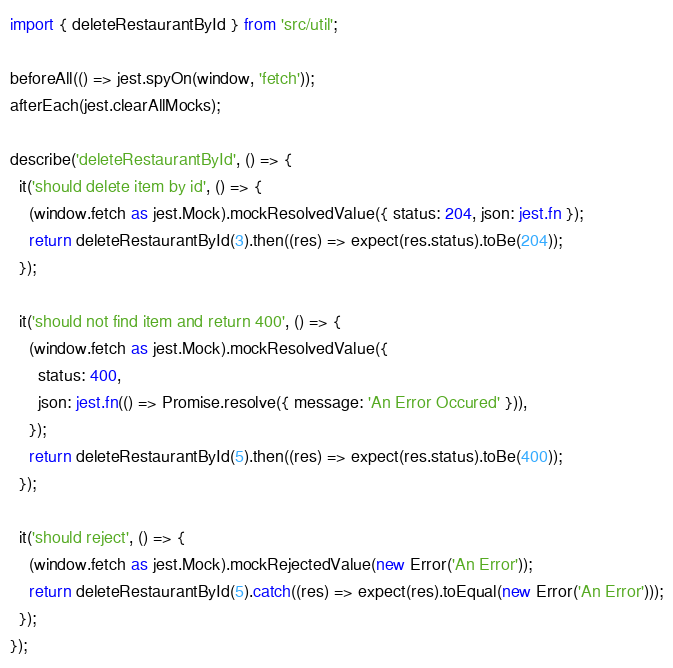<code> <loc_0><loc_0><loc_500><loc_500><_TypeScript_>import { deleteRestaurantById } from 'src/util';

beforeAll(() => jest.spyOn(window, 'fetch'));
afterEach(jest.clearAllMocks);

describe('deleteRestaurantById', () => {
  it('should delete item by id', () => {
    (window.fetch as jest.Mock).mockResolvedValue({ status: 204, json: jest.fn });
    return deleteRestaurantById(3).then((res) => expect(res.status).toBe(204));
  });

  it('should not find item and return 400', () => {
    (window.fetch as jest.Mock).mockResolvedValue({
      status: 400,
      json: jest.fn(() => Promise.resolve({ message: 'An Error Occured' })),
    });
    return deleteRestaurantById(5).then((res) => expect(res.status).toBe(400));
  });

  it('should reject', () => {
    (window.fetch as jest.Mock).mockRejectedValue(new Error('An Error'));
    return deleteRestaurantById(5).catch((res) => expect(res).toEqual(new Error('An Error')));
  });
});
</code> 